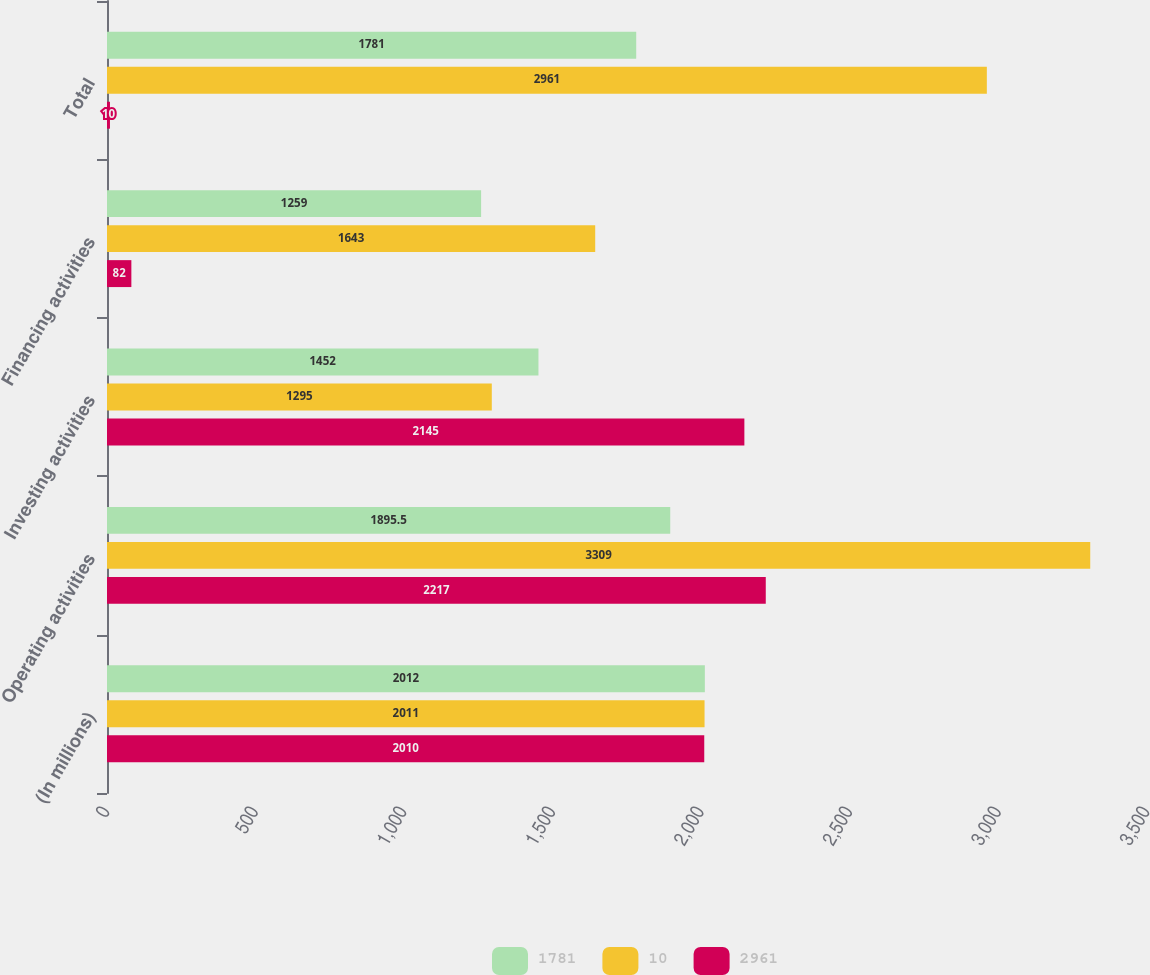<chart> <loc_0><loc_0><loc_500><loc_500><stacked_bar_chart><ecel><fcel>(In millions)<fcel>Operating activities<fcel>Investing activities<fcel>Financing activities<fcel>Total<nl><fcel>1781<fcel>2012<fcel>1895.5<fcel>1452<fcel>1259<fcel>1781<nl><fcel>10<fcel>2011<fcel>3309<fcel>1295<fcel>1643<fcel>2961<nl><fcel>2961<fcel>2010<fcel>2217<fcel>2145<fcel>82<fcel>10<nl></chart> 